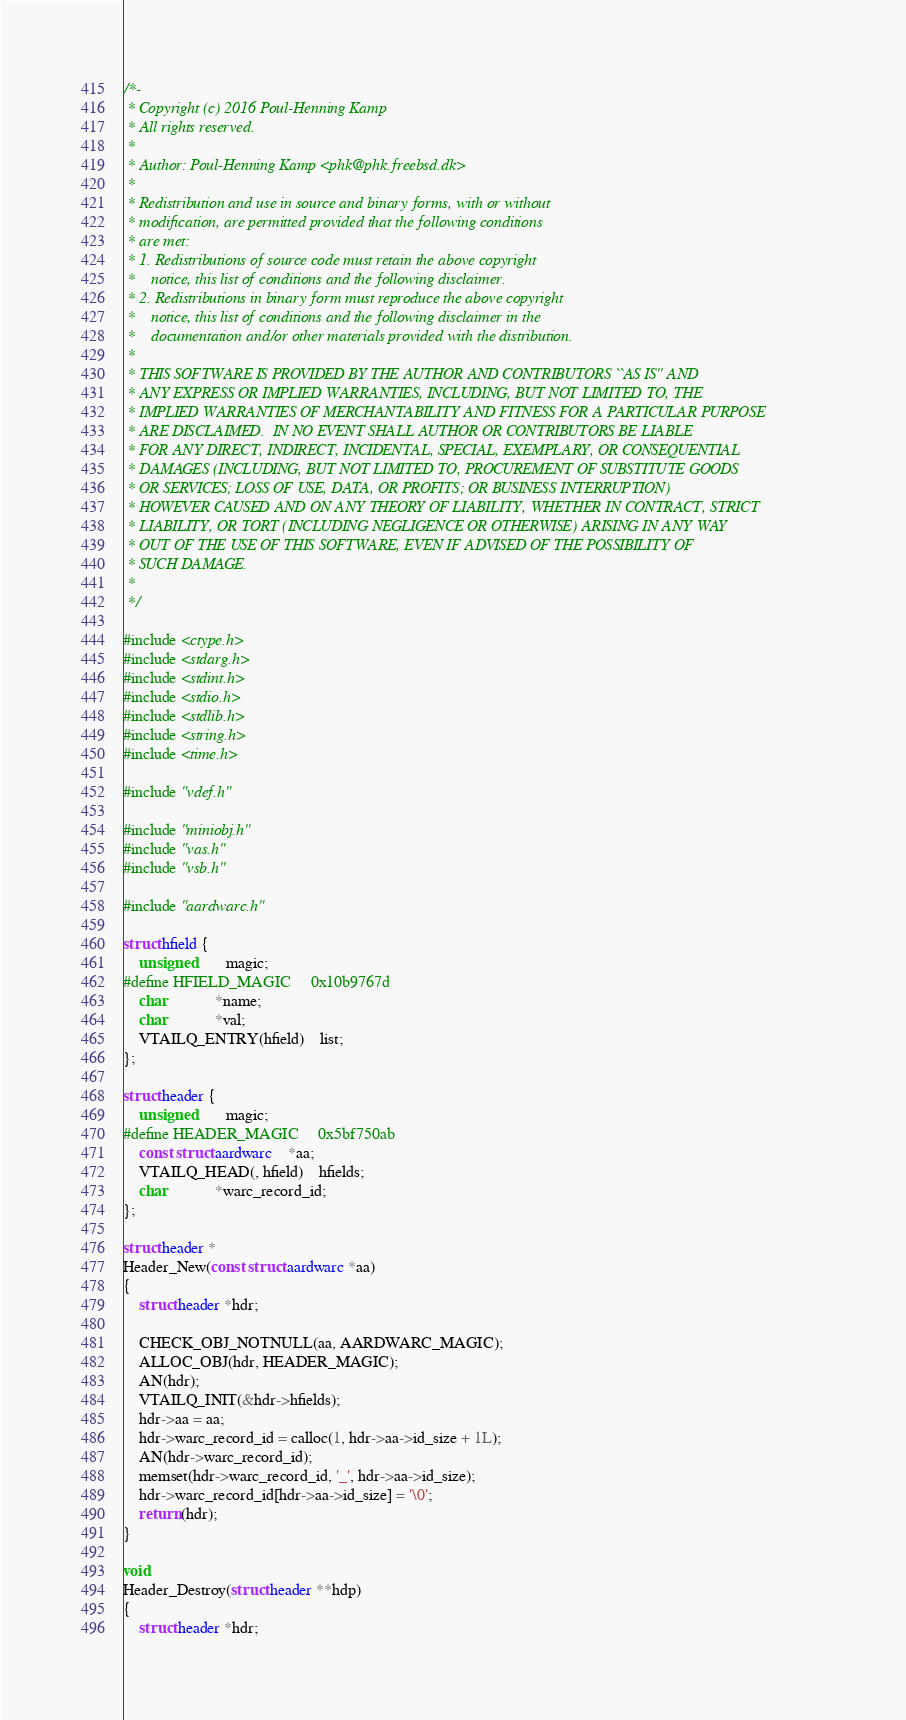Convert code to text. <code><loc_0><loc_0><loc_500><loc_500><_C_>/*-
 * Copyright (c) 2016 Poul-Henning Kamp
 * All rights reserved.
 *
 * Author: Poul-Henning Kamp <phk@phk.freebsd.dk>
 *
 * Redistribution and use in source and binary forms, with or without
 * modification, are permitted provided that the following conditions
 * are met:
 * 1. Redistributions of source code must retain the above copyright
 *    notice, this list of conditions and the following disclaimer.
 * 2. Redistributions in binary form must reproduce the above copyright
 *    notice, this list of conditions and the following disclaimer in the
 *    documentation and/or other materials provided with the distribution.
 *
 * THIS SOFTWARE IS PROVIDED BY THE AUTHOR AND CONTRIBUTORS ``AS IS'' AND
 * ANY EXPRESS OR IMPLIED WARRANTIES, INCLUDING, BUT NOT LIMITED TO, THE
 * IMPLIED WARRANTIES OF MERCHANTABILITY AND FITNESS FOR A PARTICULAR PURPOSE
 * ARE DISCLAIMED.  IN NO EVENT SHALL AUTHOR OR CONTRIBUTORS BE LIABLE
 * FOR ANY DIRECT, INDIRECT, INCIDENTAL, SPECIAL, EXEMPLARY, OR CONSEQUENTIAL
 * DAMAGES (INCLUDING, BUT NOT LIMITED TO, PROCUREMENT OF SUBSTITUTE GOODS
 * OR SERVICES; LOSS OF USE, DATA, OR PROFITS; OR BUSINESS INTERRUPTION)
 * HOWEVER CAUSED AND ON ANY THEORY OF LIABILITY, WHETHER IN CONTRACT, STRICT
 * LIABILITY, OR TORT (INCLUDING NEGLIGENCE OR OTHERWISE) ARISING IN ANY WAY
 * OUT OF THE USE OF THIS SOFTWARE, EVEN IF ADVISED OF THE POSSIBILITY OF
 * SUCH DAMAGE.
 *
 */

#include <ctype.h>
#include <stdarg.h>
#include <stdint.h>
#include <stdio.h>
#include <stdlib.h>
#include <string.h>
#include <time.h>

#include "vdef.h"

#include "miniobj.h"
#include "vas.h"
#include "vsb.h"

#include "aardwarc.h"

struct hfield {
	unsigned		magic;
#define HFIELD_MAGIC		0x10b9767d
	char			*name;
	char			*val;
	VTAILQ_ENTRY(hfield)	list;
};

struct header {
	unsigned		magic;
#define HEADER_MAGIC		0x5bf750ab
	const struct aardwarc	*aa;
	VTAILQ_HEAD(, hfield)	hfields;
	char			*warc_record_id;
};

struct header *
Header_New(const struct aardwarc *aa)
{
	struct header *hdr;

	CHECK_OBJ_NOTNULL(aa, AARDWARC_MAGIC);
	ALLOC_OBJ(hdr, HEADER_MAGIC);
	AN(hdr);
	VTAILQ_INIT(&hdr->hfields);
	hdr->aa = aa;
	hdr->warc_record_id = calloc(1, hdr->aa->id_size + 1L);
	AN(hdr->warc_record_id);
	memset(hdr->warc_record_id, '_', hdr->aa->id_size);
	hdr->warc_record_id[hdr->aa->id_size] = '\0';
	return (hdr);
}

void
Header_Destroy(struct header **hdp)
{
	struct header *hdr;</code> 